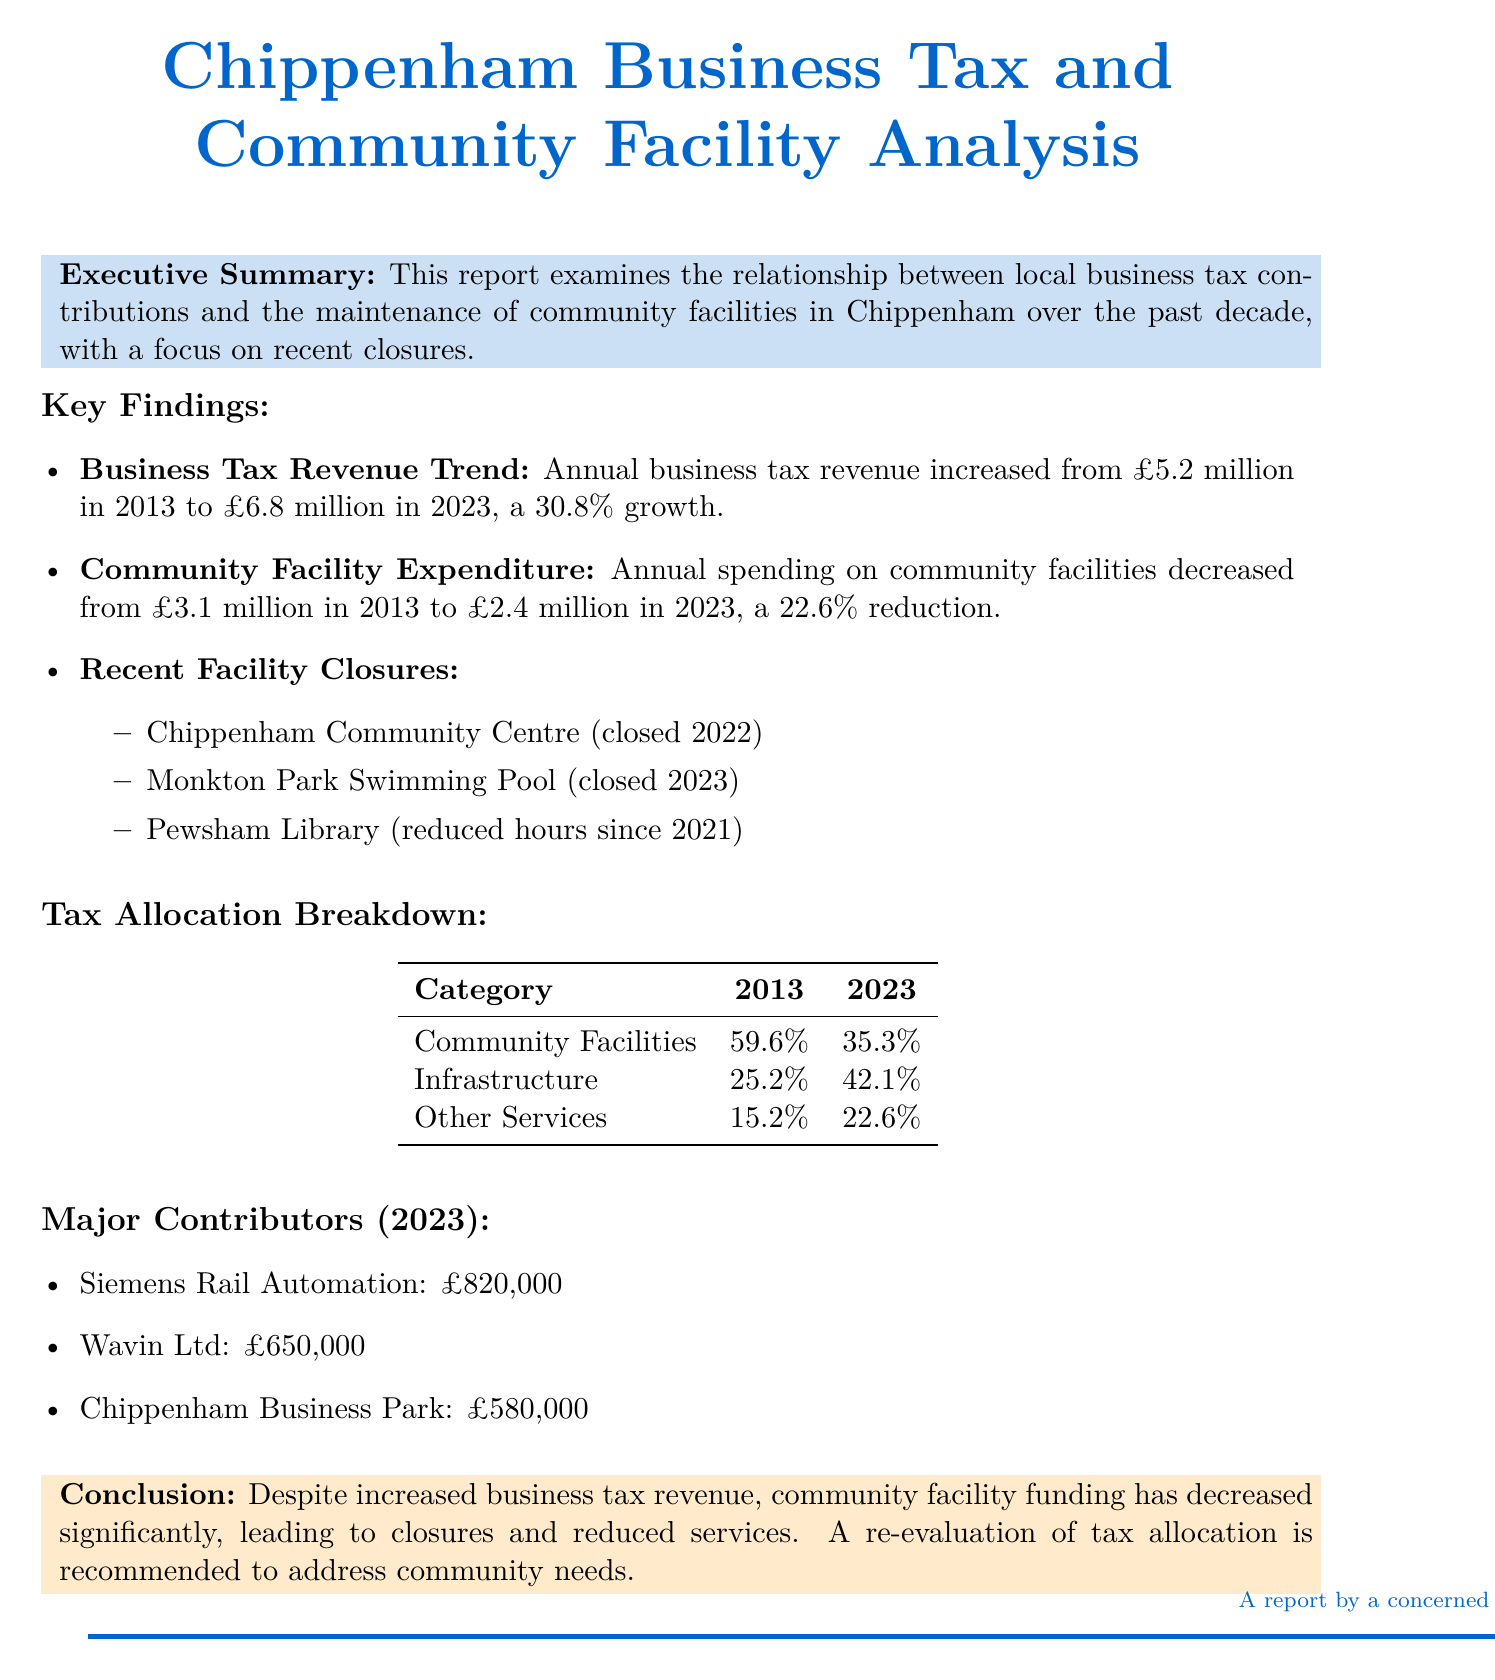What was the total business tax revenue in 2023? The annual business tax revenue in 2023 is stated in the document as £6.8 million.
Answer: £6.8 million What percentage of tax was allocated to Community Facilities in 2013? The document provides a breakdown of tax allocation in 2013, showing that 59.6% was allocated to Community Facilities.
Answer: 59.6% Which community facility closed in 2022? The report lists the Chippenham Community Centre as one of the facilities that closed in 2022.
Answer: Chippenham Community Centre What is the annual contribution of Siemens Rail Automation in 2023? The annual contribution of Siemens Rail Automation is specified in the document as £820,000.
Answer: £820,000 What was the percentage decrease in community facility expenditure from 2013 to 2023? The report mentions that annual spending on community facilities decreased by 22.6% from 2013 to 2023.
Answer: 22.6% How many major contributors are listed for 2023? The document lists three major contributors for the year 2023.
Answer: Three What facility had reduced hours since 2021? According to the report, Pewsham Library has had reduced hours since 2021.
Answer: Pewsham Library What is the primary conclusion of the report? The conclusion of the report indicates that despite increased business tax revenue, community facility funding has decreased significantly.
Answer: Decreased funding for community facilities 